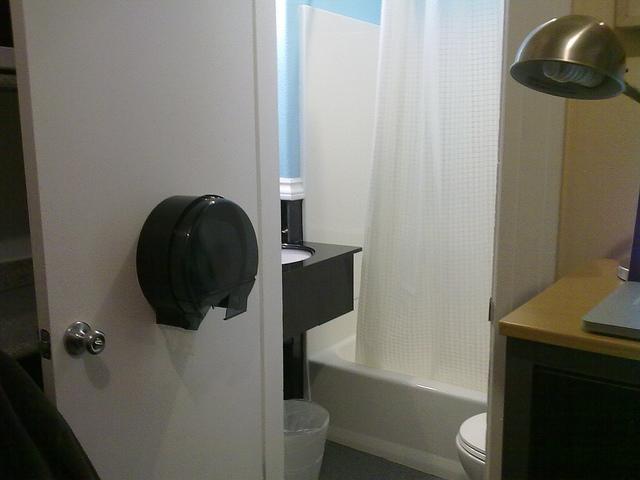Is someone in the bathroom?
Quick response, please. No. What is hanging on the wall outside the bathroom?
Answer briefly. Picture. Is the door open?
Give a very brief answer. Yes. Is the lid up?
Give a very brief answer. No. What color is the sink?
Give a very brief answer. Black. 